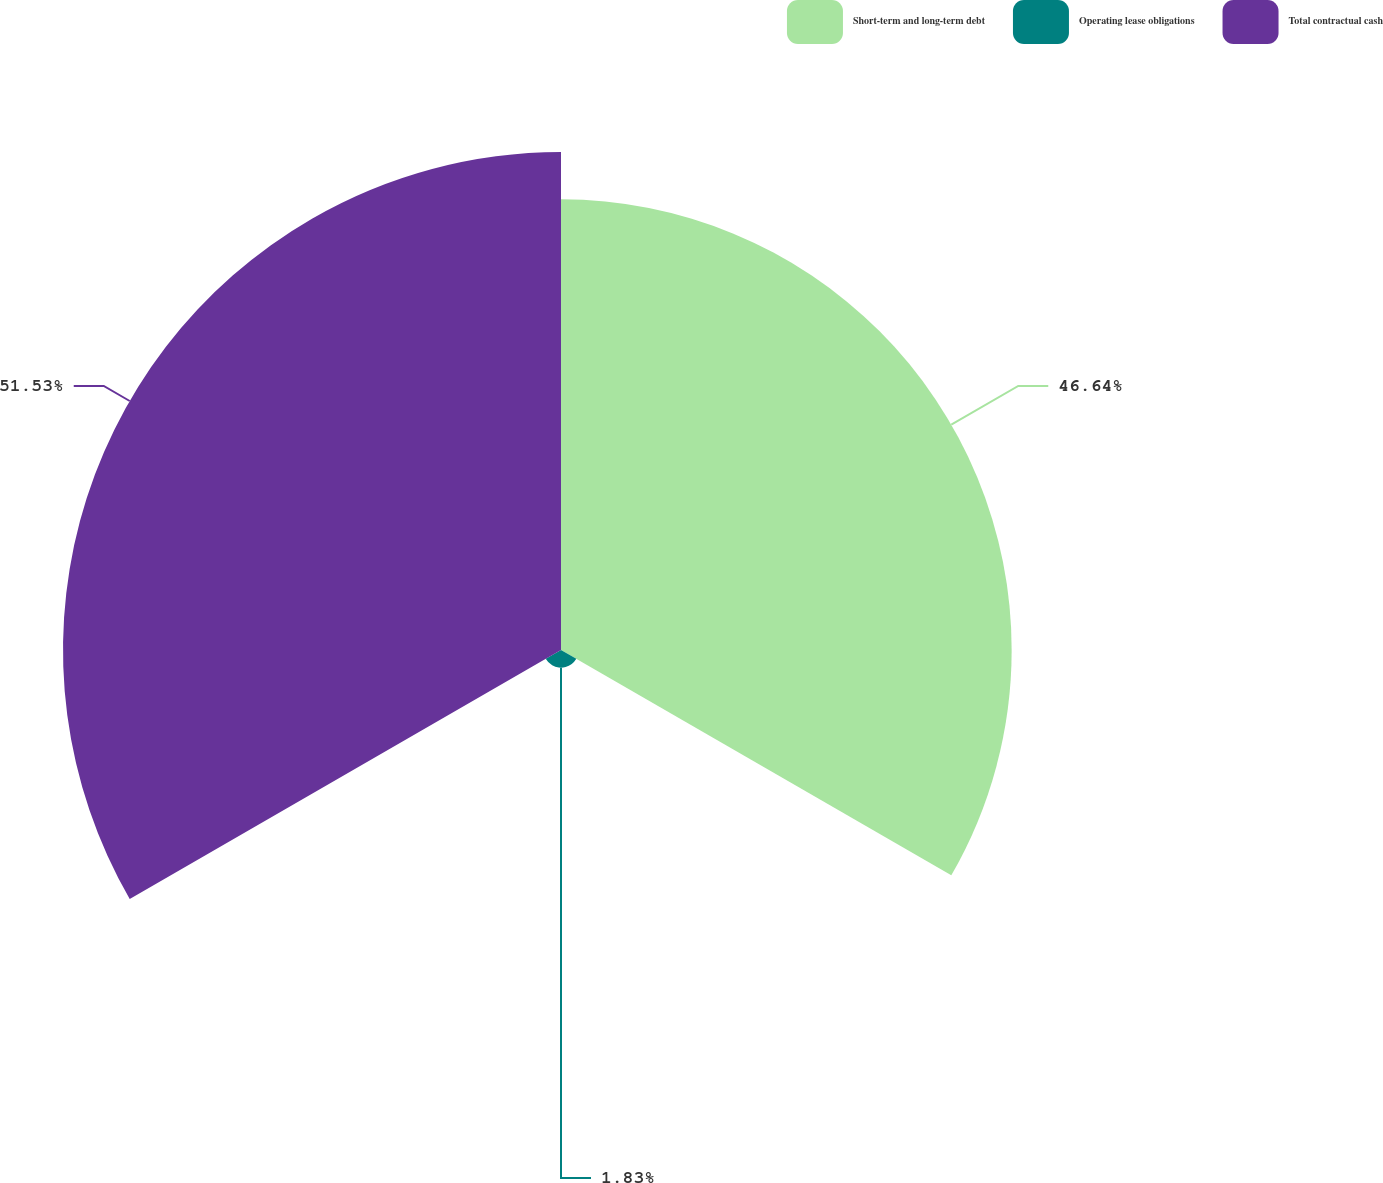Convert chart. <chart><loc_0><loc_0><loc_500><loc_500><pie_chart><fcel>Short-term and long-term debt<fcel>Operating lease obligations<fcel>Total contractual cash<nl><fcel>46.64%<fcel>1.83%<fcel>51.54%<nl></chart> 